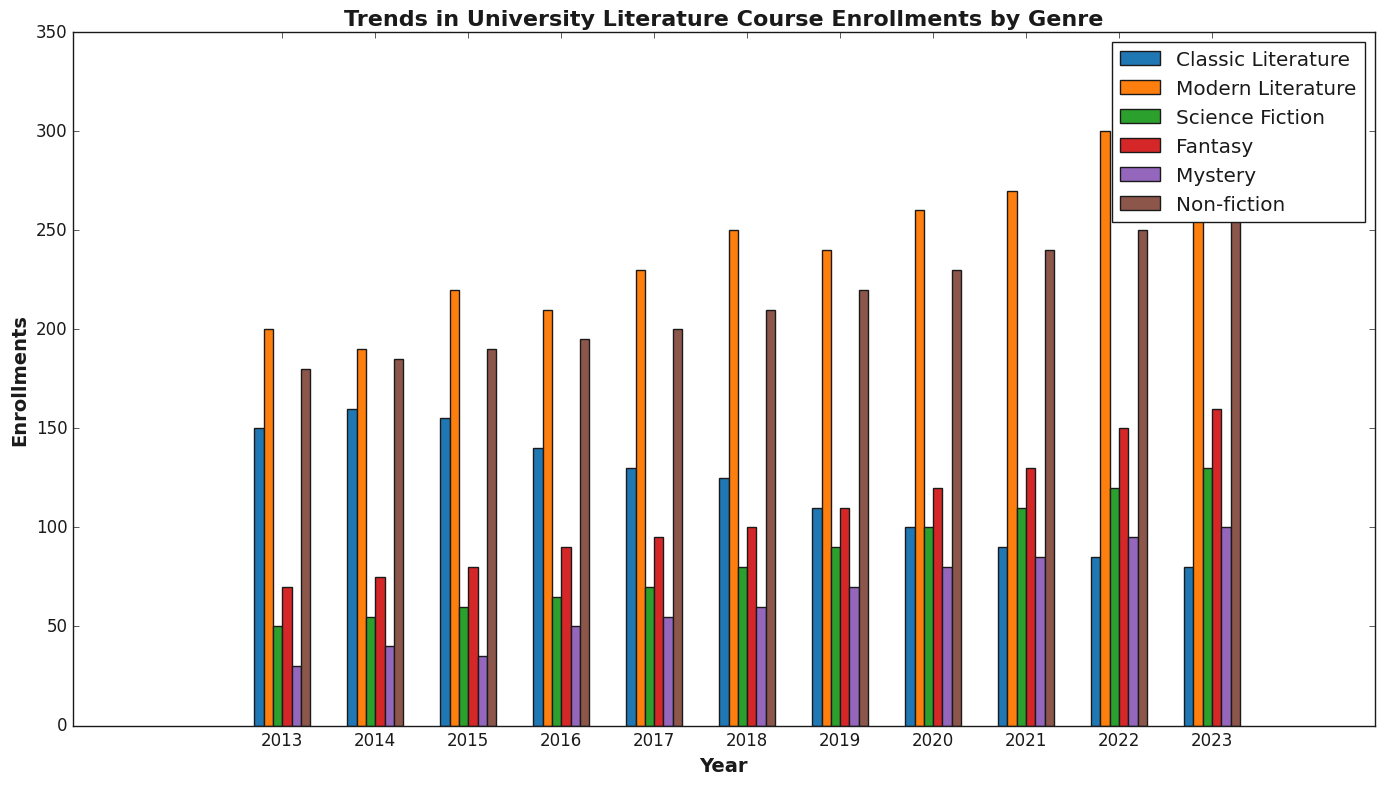What genre had the highest number of enrollments in 2023? Looking at the bars for the year 2023, we see that the bar representing Modern Literature is the tallest.
Answer: Modern Literature How did the enrollment in Classic Literature change from 2013 to 2023? To find the change in enrollments over the years for Classic Literature, we subtract the value in 2023 (80) from the value in 2013 (150). The change is 150 - 80 = 70.
Answer: Decreased by 70 Which genre showed the most consistent increase in enrollments over the 10-year period? By comparing the trends for each genre, we can see that Non-fiction shows a steady and consistent increase every year from 2013 to 2023.
Answer: Non-fiction How did enrollments in Fantasy courses change from 2015 to 2020? Checking the enrollments for Fantasy in 2015 (80) and 2020 (120) and calculating the difference, we get 120 - 80 = 40.
Answer: Increased by 40 In which year did Mystery courses see the highest jump in enrollments compared to the previous year? By comparing each year’s data for Mystery, the highest jump occurred from 2021 (85) to 2022 (95), which is an increase of 10.
Answer: 2022 Which genres had more enrollments in 2018 compared to 2017? Comparing the enrollment values for 2017 and 2018 for each genre, both Modern Literature (230 to 250) and Non-fiction (200 to 210) show an increase.
Answer: Modern Literature, Non-fiction What is the average enrollment in Science Fiction courses over the 10 years? To find the average, add up the enrollments for Science Fiction from 2013 to 2023 (50+55+60+65+70+80+90+100+110+120+130) = 930 and then divide by 11 years. The average is 930/11 ≈ 84.55.
Answer: 84.55 How did the total enrollments (sum) for all genres change from 2013 to 2023? Calculate the total enrollments for each year by summing up the enrollments across all genres for 2013 (150+200+50+70+30+180 = 680) and 2023 (80+310+130+160+100+260 = 1040). The change is 1040 - 680 = 360.
Answer: Increased by 360 Which genre experienced the least growth in enrollments from 2013 to 2023? By calculating the difference for all genres, we find the difference for Classic Literature is 80 - 150 = -70, meaning it has the least growth since it decreased.
Answer: Classic Literature 